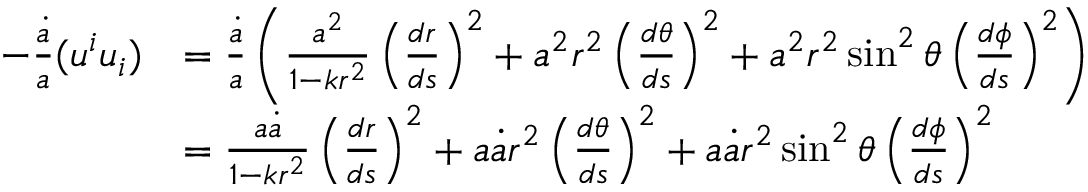<formula> <loc_0><loc_0><loc_500><loc_500>\begin{array} { r l } { - \frac { \dot { a } } { a } ( u ^ { i } u _ { i } ) } & { = \frac { \dot { a } } { a } \left ( \frac { a ^ { 2 } } { 1 - k r ^ { 2 } } \left ( \frac { d r } { d s } \right ) ^ { 2 } + a ^ { 2 } r ^ { 2 } \left ( \frac { d \theta } { d s } \right ) ^ { 2 } + a ^ { 2 } r ^ { 2 } \sin ^ { 2 } \theta \left ( \frac { d \phi } { d s } \right ) ^ { 2 } \right ) } \\ & { = \frac { a \dot { a } } { 1 - k r ^ { 2 } } \left ( \frac { d r } { d s } \right ) ^ { 2 } + a \dot { a } r ^ { 2 } \left ( \frac { d \theta } { d s } \right ) ^ { 2 } + a \dot { a } r ^ { 2 } \sin ^ { 2 } \theta \left ( \frac { d \phi } { d s } \right ) ^ { 2 } } \end{array}</formula> 